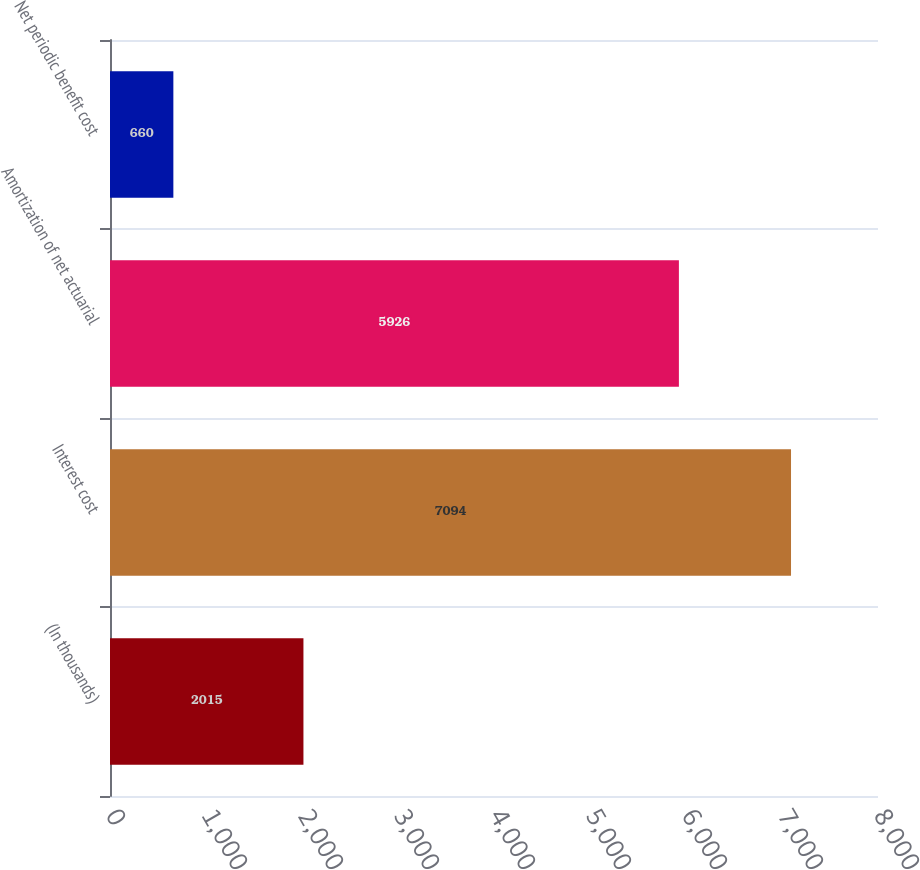Convert chart to OTSL. <chart><loc_0><loc_0><loc_500><loc_500><bar_chart><fcel>(In thousands)<fcel>Interest cost<fcel>Amortization of net actuarial<fcel>Net periodic benefit cost<nl><fcel>2015<fcel>7094<fcel>5926<fcel>660<nl></chart> 